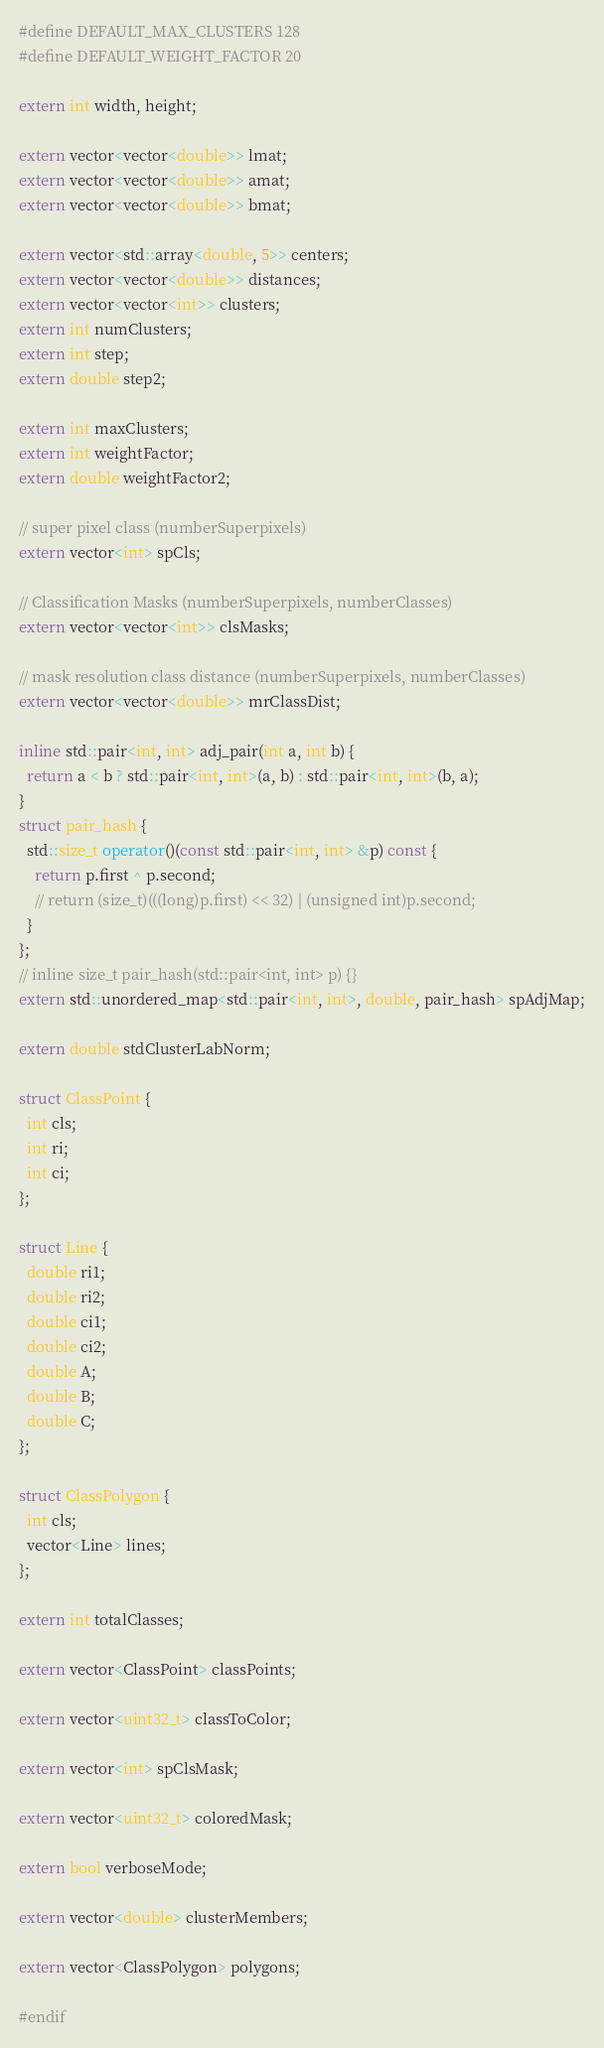<code> <loc_0><loc_0><loc_500><loc_500><_C++_>#define DEFAULT_MAX_CLUSTERS 128
#define DEFAULT_WEIGHT_FACTOR 20

extern int width, height;

extern vector<vector<double>> lmat;
extern vector<vector<double>> amat;
extern vector<vector<double>> bmat;

extern vector<std::array<double, 5>> centers;
extern vector<vector<double>> distances;
extern vector<vector<int>> clusters;
extern int numClusters;
extern int step;
extern double step2;

extern int maxClusters;
extern int weightFactor;
extern double weightFactor2;

// super pixel class (numberSuperpixels)
extern vector<int> spCls;

// Classification Masks (numberSuperpixels, numberClasses)
extern vector<vector<int>> clsMasks;

// mask resolution class distance (numberSuperpixels, numberClasses)
extern vector<vector<double>> mrClassDist;

inline std::pair<int, int> adj_pair(int a, int b) {
  return a < b ? std::pair<int, int>(a, b) : std::pair<int, int>(b, a);
}
struct pair_hash {
  std::size_t operator()(const std::pair<int, int> &p) const {
    return p.first ^ p.second;
    // return (size_t)(((long)p.first) << 32) | (unsigned int)p.second;
  }
};
// inline size_t pair_hash(std::pair<int, int> p) {}
extern std::unordered_map<std::pair<int, int>, double, pair_hash> spAdjMap;

extern double stdClusterLabNorm;

struct ClassPoint {
  int cls;
  int ri;
  int ci;
};

struct Line {
  double ri1;
  double ri2;
  double ci1;
  double ci2;
  double A;
  double B;
  double C;
};

struct ClassPolygon {
  int cls;
  vector<Line> lines;
};

extern int totalClasses;

extern vector<ClassPoint> classPoints;

extern vector<uint32_t> classToColor;

extern vector<int> spClsMask;

extern vector<uint32_t> coloredMask;

extern bool verboseMode;

extern vector<double> clusterMembers;

extern vector<ClassPolygon> polygons;

#endif
</code> 